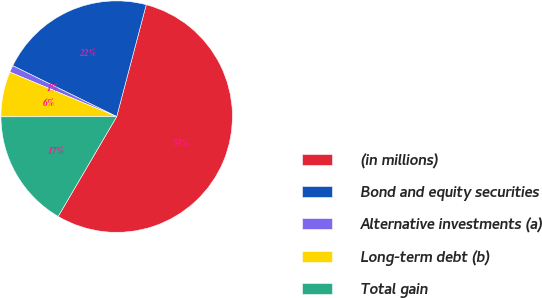Convert chart to OTSL. <chart><loc_0><loc_0><loc_500><loc_500><pie_chart><fcel>(in millions)<fcel>Bond and equity securities<fcel>Alternative investments (a)<fcel>Long-term debt (b)<fcel>Total gain<nl><fcel>54.33%<fcel>21.86%<fcel>0.97%<fcel>6.31%<fcel>16.53%<nl></chart> 